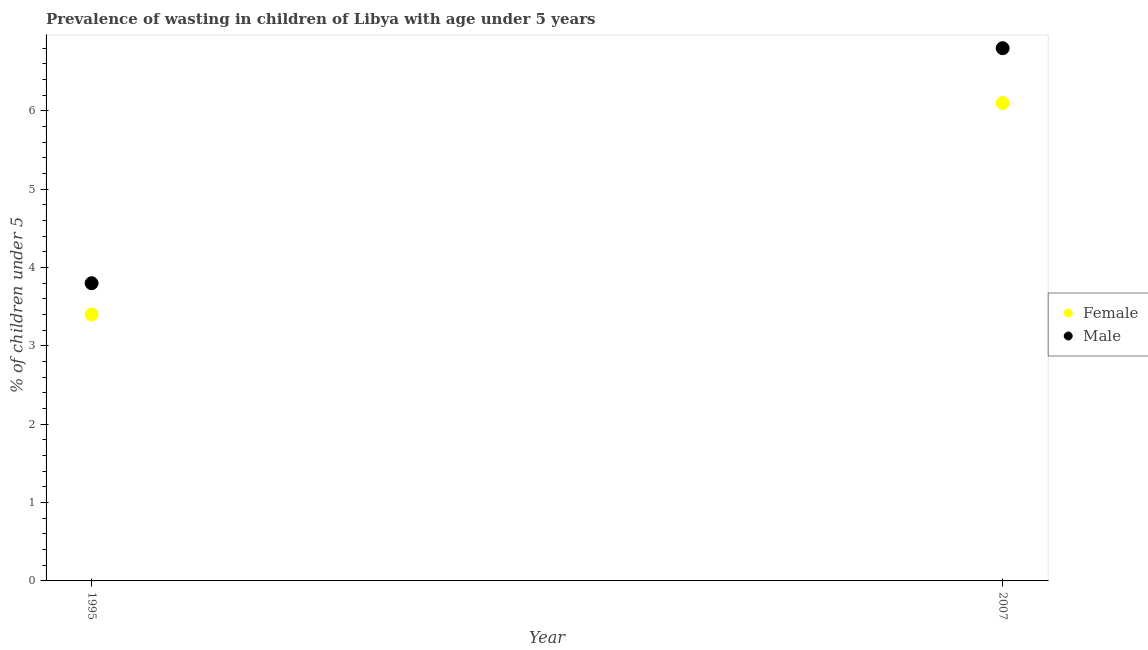How many different coloured dotlines are there?
Offer a very short reply. 2. Is the number of dotlines equal to the number of legend labels?
Provide a succinct answer. Yes. What is the percentage of undernourished male children in 2007?
Give a very brief answer. 6.8. Across all years, what is the maximum percentage of undernourished male children?
Make the answer very short. 6.8. Across all years, what is the minimum percentage of undernourished female children?
Your response must be concise. 3.4. What is the total percentage of undernourished female children in the graph?
Make the answer very short. 9.5. What is the difference between the percentage of undernourished male children in 1995 and that in 2007?
Provide a short and direct response. -3. What is the difference between the percentage of undernourished male children in 2007 and the percentage of undernourished female children in 1995?
Make the answer very short. 3.4. What is the average percentage of undernourished male children per year?
Your response must be concise. 5.3. In the year 2007, what is the difference between the percentage of undernourished female children and percentage of undernourished male children?
Offer a very short reply. -0.7. What is the ratio of the percentage of undernourished male children in 1995 to that in 2007?
Ensure brevity in your answer.  0.56. Is the percentage of undernourished male children in 1995 less than that in 2007?
Give a very brief answer. Yes. In how many years, is the percentage of undernourished male children greater than the average percentage of undernourished male children taken over all years?
Provide a succinct answer. 1. Is the percentage of undernourished male children strictly less than the percentage of undernourished female children over the years?
Your answer should be compact. No. How many dotlines are there?
Keep it short and to the point. 2. Are the values on the major ticks of Y-axis written in scientific E-notation?
Provide a succinct answer. No. Where does the legend appear in the graph?
Offer a very short reply. Center right. How many legend labels are there?
Provide a succinct answer. 2. How are the legend labels stacked?
Your answer should be compact. Vertical. What is the title of the graph?
Make the answer very short. Prevalence of wasting in children of Libya with age under 5 years. Does "Investment" appear as one of the legend labels in the graph?
Keep it short and to the point. No. What is the label or title of the Y-axis?
Make the answer very short.  % of children under 5. What is the  % of children under 5 in Female in 1995?
Keep it short and to the point. 3.4. What is the  % of children under 5 of Male in 1995?
Offer a very short reply. 3.8. What is the  % of children under 5 in Female in 2007?
Provide a short and direct response. 6.1. What is the  % of children under 5 of Male in 2007?
Give a very brief answer. 6.8. Across all years, what is the maximum  % of children under 5 of Female?
Provide a succinct answer. 6.1. Across all years, what is the maximum  % of children under 5 of Male?
Your answer should be compact. 6.8. Across all years, what is the minimum  % of children under 5 in Female?
Offer a very short reply. 3.4. Across all years, what is the minimum  % of children under 5 in Male?
Provide a succinct answer. 3.8. What is the total  % of children under 5 in Female in the graph?
Provide a succinct answer. 9.5. What is the difference between the  % of children under 5 in Male in 1995 and that in 2007?
Offer a very short reply. -3. What is the average  % of children under 5 in Female per year?
Your response must be concise. 4.75. What is the average  % of children under 5 of Male per year?
Offer a terse response. 5.3. In the year 1995, what is the difference between the  % of children under 5 of Female and  % of children under 5 of Male?
Provide a succinct answer. -0.4. In the year 2007, what is the difference between the  % of children under 5 in Female and  % of children under 5 in Male?
Your response must be concise. -0.7. What is the ratio of the  % of children under 5 of Female in 1995 to that in 2007?
Ensure brevity in your answer.  0.56. What is the ratio of the  % of children under 5 in Male in 1995 to that in 2007?
Your response must be concise. 0.56. What is the difference between the highest and the lowest  % of children under 5 in Female?
Ensure brevity in your answer.  2.7. 